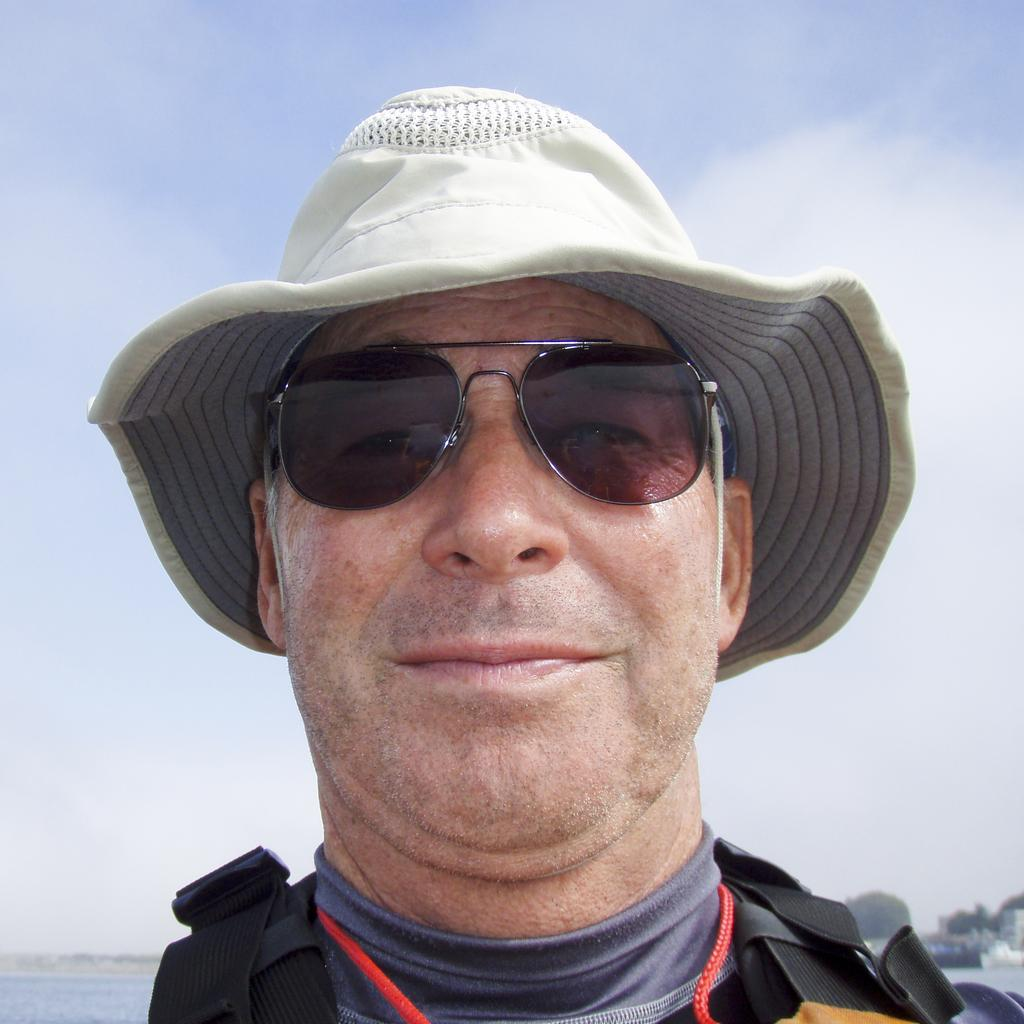What is the person in the image wearing on their head? The person is wearing a cap. What color is the t-shirt the person is wearing? The person is wearing a gray t-shirt. What type of eyewear is the person wearing? The person is wearing sunglasses. What is the person's facial expression in the image? The person is smiling. What can be seen in the background of the image? There is water, trees, and clouds in the sky in the background of the image. What color is the sky in the image? The sky is blue in the image. How many quince are being compared in the image? There are no quince present in the image, and no comparison is being made. What is the value of the dime on the person's forehead in the image? There is no dime present on the person's forehead in the image. 